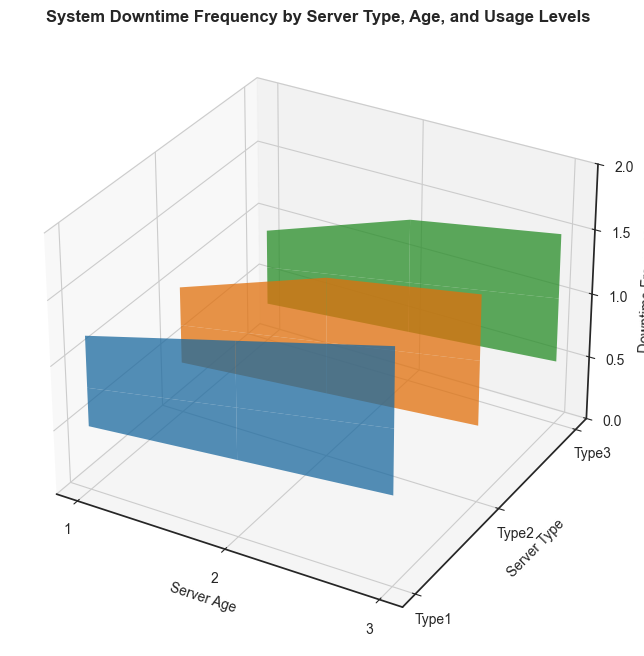What server type has the highest downtime frequency when usage level is high and server age is 3? Find the Z values corresponding to each (Server_Type, 'High', 3) tuple, and compare them. The highest value is for Server_Type 1, with a downtime frequency of 1.8.
Answer: Type1 Does downtime frequency increase with server age across all server types? Observe the Z axis for each Server_Type across the X axis for increasing Server_Age. For all Server_Types, downtime frequency increases with server age.
Answer: Yes Which server type shows the least downtime frequency at low usage levels regardless of age? Compare the Z values for each Server_Type at 'Low' usage level across all server ages. Server_Type 3 has the lowest downtime frequency at 'Low' usage levels.
Answer: Type3 How much higher is the downtime frequency for Server_Type 2 with high usage at age 3 compared to age 1? Subtract the downtime frequency of (Server_Type 2, 'High', 1) from (Server_Type 2, 'High', 3). The values are 1.6 and 1.0, respectively. The difference is 0.6.
Answer: 0.6 What is the average downtime frequency for Server_Type 1 across all ages and usage levels? Sum all downtime frequencies for Server_Type 1 and divide by the number of data points (3 ages * 3 usage levels = 9). The sum is 0.5+0.8+1.2+0.6+1.0+1.5+0.7+1.2+1.8 = 9.3, and the average is 9.3/9.
Answer: 1.033 For Server_Type 3, how does the downtime frequency change from low to medium usage at age 2? Subtract the downtime frequency at (Server_Type 3, 'Low', 2) from (Server_Type 3, 'Medium', 2). The values are 0.4 and 0.8, respectively. The change is 0.4.
Answer: 0.4 Which Server_Type has the steepest increase in downtime frequency from low to high usage levels at age 1? Calculate the differences in downtime frequencies for each Server_Type from 'Low' to 'High' usage levels at age 1. The steepest increase is for Server_Type 1 (from 0.5 to 1.2, an increase of 0.7).
Answer: Type1 At age 2, what is the downtime frequency difference between Server_Type 1 and Server_Type 2 at medium usage levels? Subtract the downtime frequency of (Server_Type 2, 'Medium', 2) from (Server_Type 1, 'Medium', 2). The values are 1.0 and 0.9 respectively, so the difference is 0.1.
Answer: 0.1 